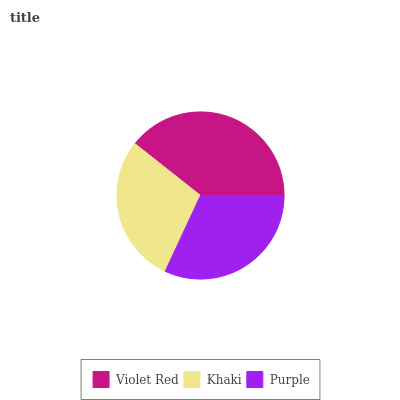Is Khaki the minimum?
Answer yes or no. Yes. Is Violet Red the maximum?
Answer yes or no. Yes. Is Purple the minimum?
Answer yes or no. No. Is Purple the maximum?
Answer yes or no. No. Is Purple greater than Khaki?
Answer yes or no. Yes. Is Khaki less than Purple?
Answer yes or no. Yes. Is Khaki greater than Purple?
Answer yes or no. No. Is Purple less than Khaki?
Answer yes or no. No. Is Purple the high median?
Answer yes or no. Yes. Is Purple the low median?
Answer yes or no. Yes. Is Violet Red the high median?
Answer yes or no. No. Is Khaki the low median?
Answer yes or no. No. 